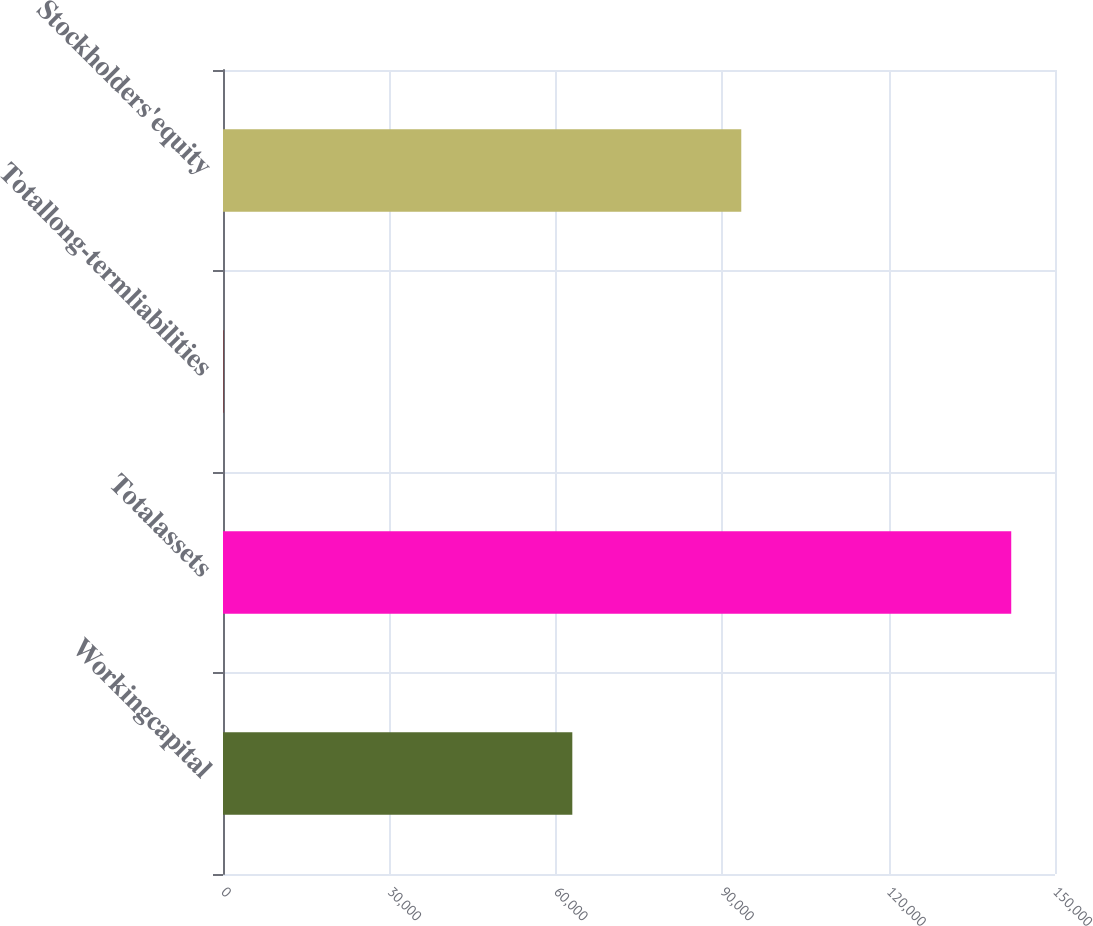Convert chart. <chart><loc_0><loc_0><loc_500><loc_500><bar_chart><fcel>Workingcapital<fcel>Totalassets<fcel>Totallong-termliabilities<fcel>Stockholders'equity<nl><fcel>62978<fcel>142110<fcel>64<fcel>93438<nl></chart> 